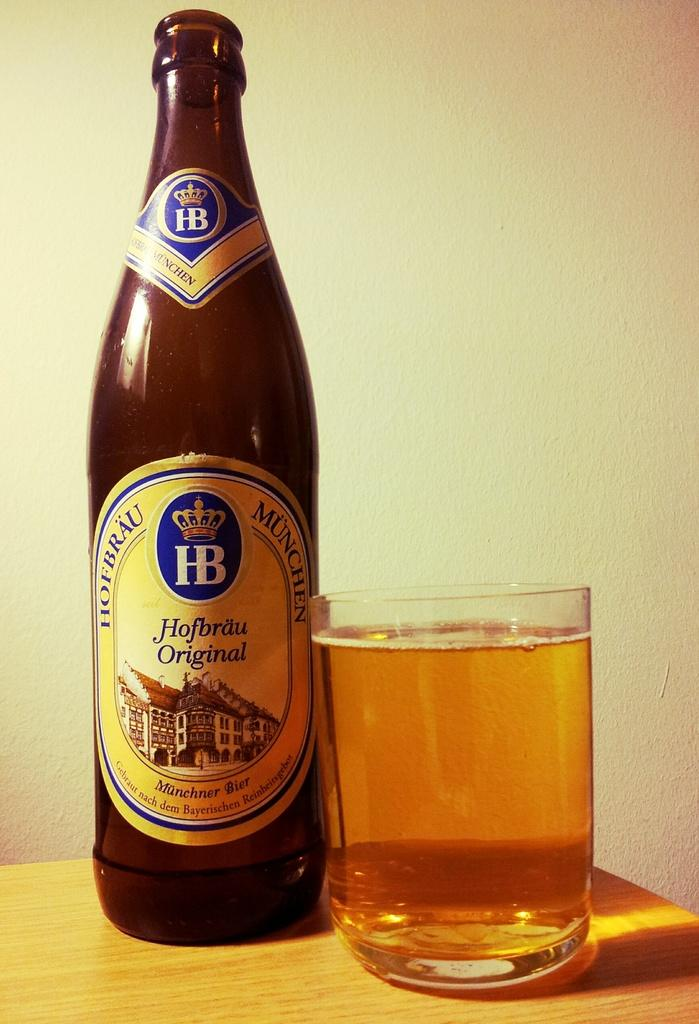<image>
Create a compact narrative representing the image presented. A bottle of Hofbrau Original beer has been poured into a drinking glass beside it. 